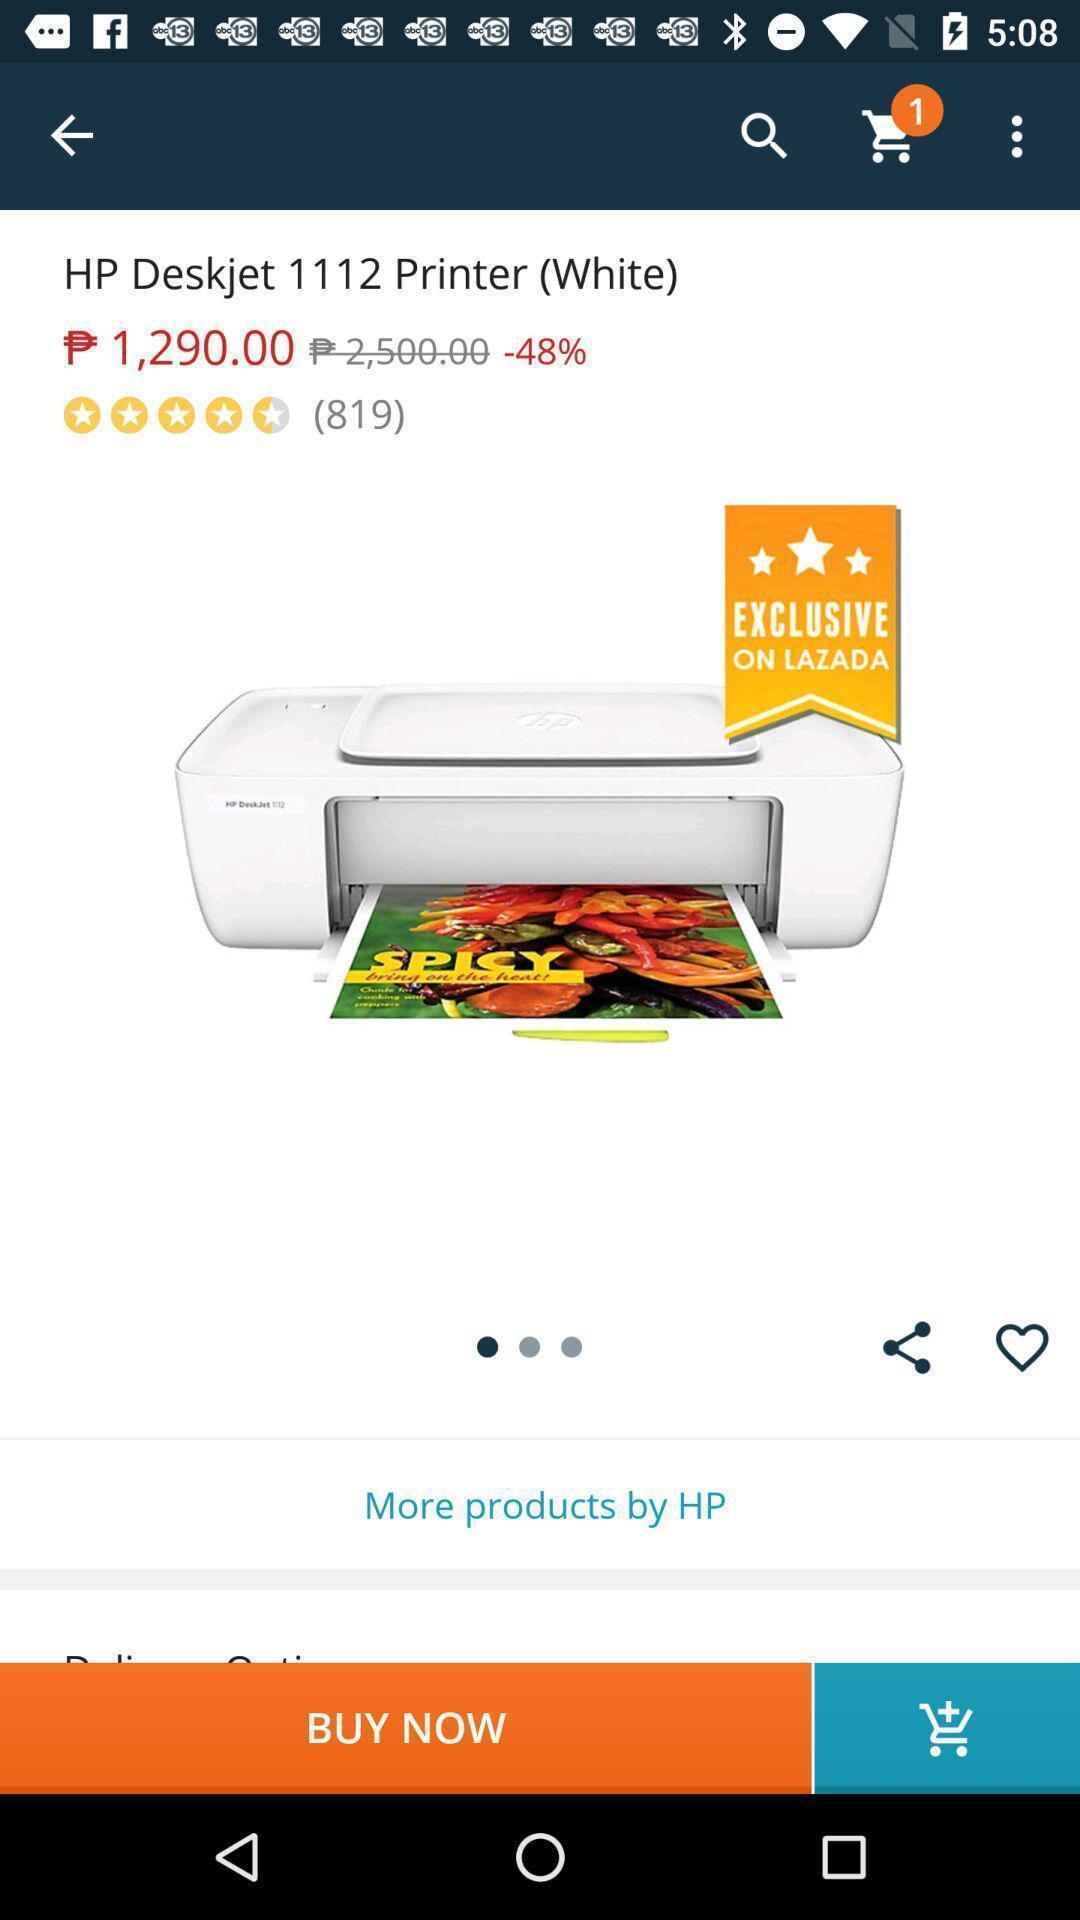Tell me what you see in this picture. Page displaying the product with price to buy. 